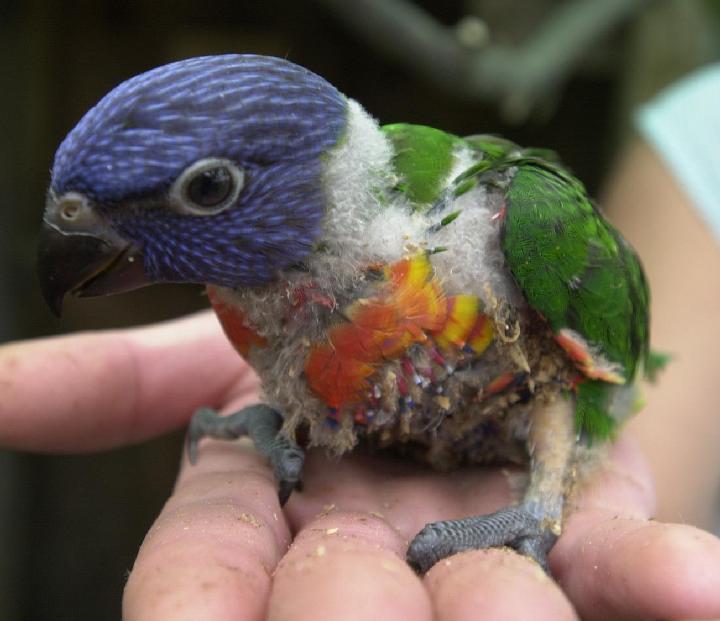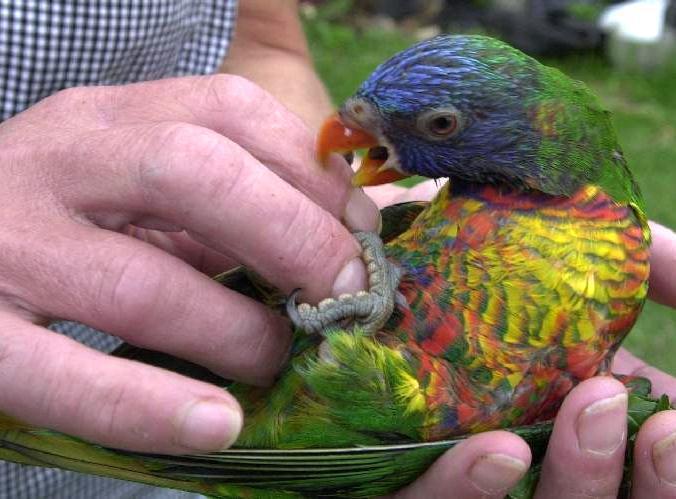The first image is the image on the left, the second image is the image on the right. For the images shown, is this caption "There is at least two parrots in the right image." true? Answer yes or no. No. The first image is the image on the left, the second image is the image on the right. Examine the images to the left and right. Is the description "At least one image shows a colorful bird interacting with a human hand" accurate? Answer yes or no. Yes. 